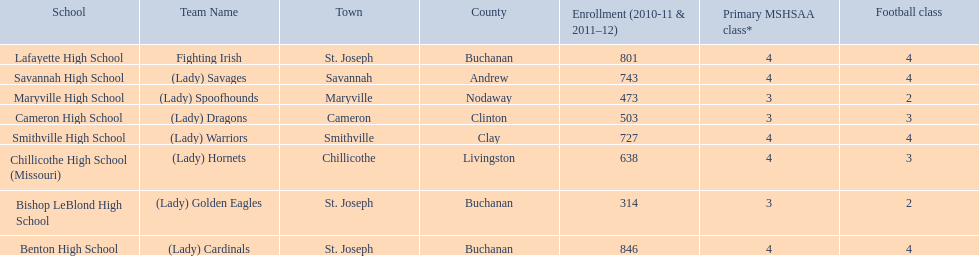What are all of the schools? Benton High School, Bishop LeBlond High School, Cameron High School, Chillicothe High School (Missouri), Lafayette High School, Maryville High School, Savannah High School, Smithville High School. How many football classes do they have? 4, 2, 3, 3, 4, 2, 4, 4. What about their enrollment? 846, 314, 503, 638, 801, 473, 743, 727. Which schools have 3 football classes? Cameron High School, Chillicothe High School (Missouri). And of those schools, which has 638 students? Chillicothe High School (Missouri). 